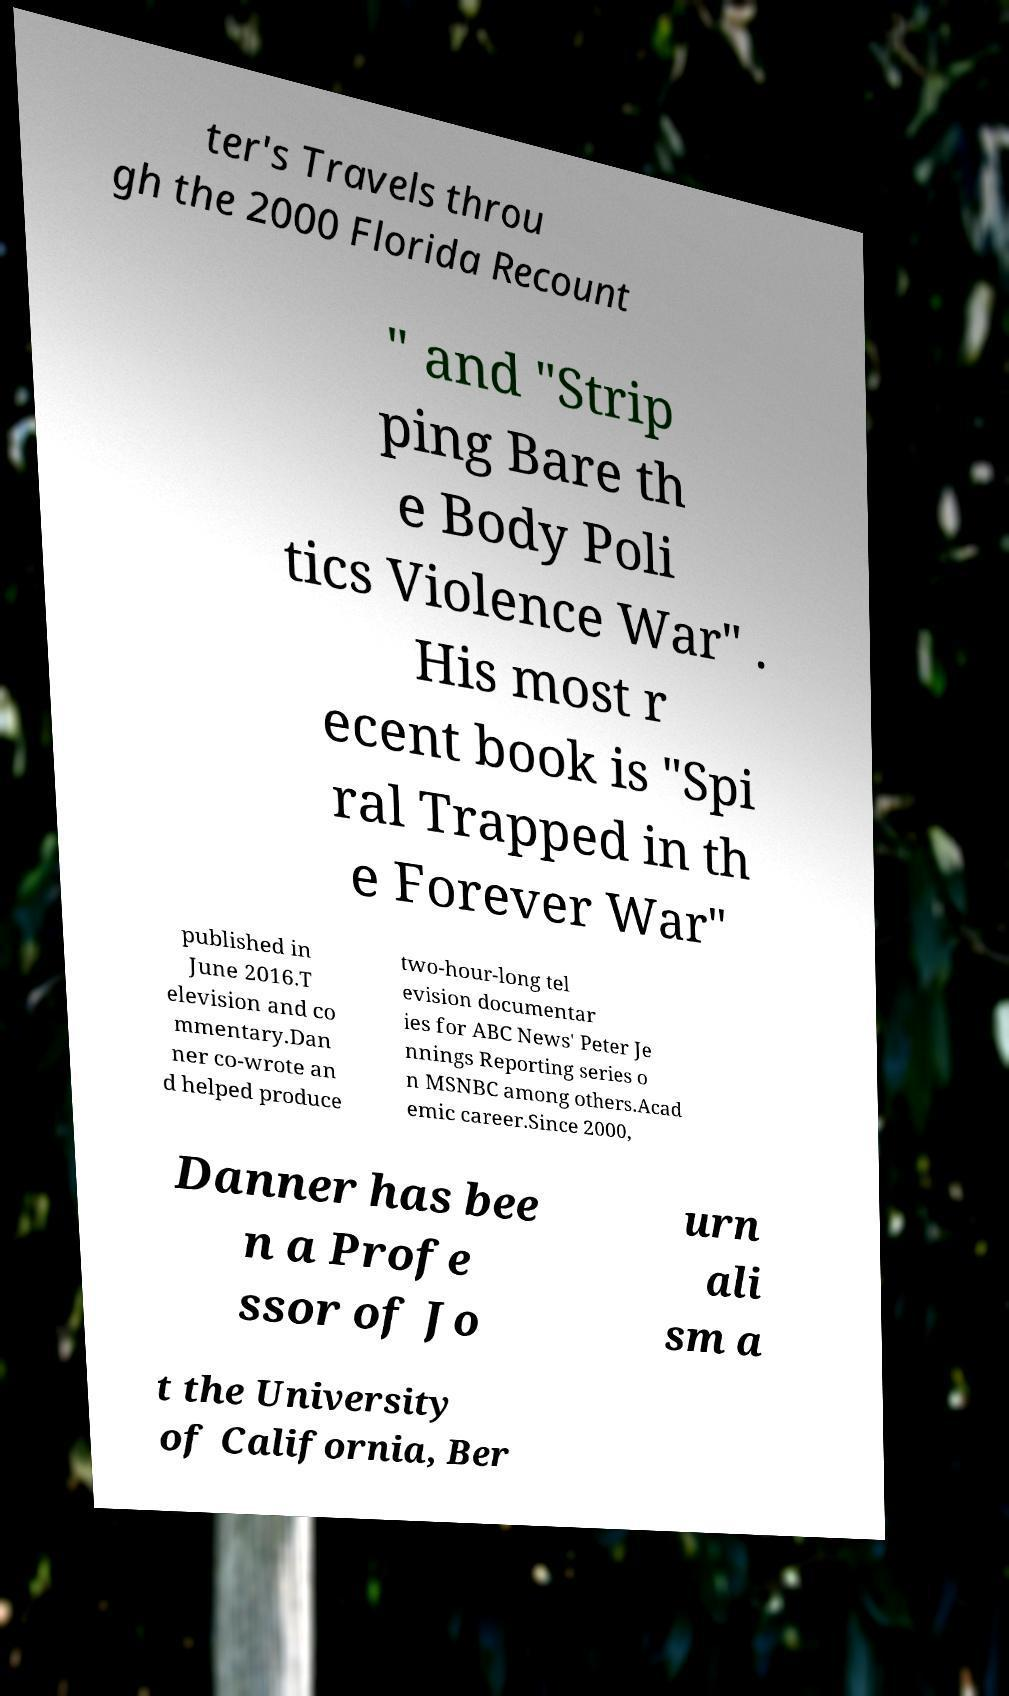What messages or text are displayed in this image? I need them in a readable, typed format. ter's Travels throu gh the 2000 Florida Recount " and "Strip ping Bare th e Body Poli tics Violence War" . His most r ecent book is "Spi ral Trapped in th e Forever War" published in June 2016.T elevision and co mmentary.Dan ner co-wrote an d helped produce two-hour-long tel evision documentar ies for ABC News' Peter Je nnings Reporting series o n MSNBC among others.Acad emic career.Since 2000, Danner has bee n a Profe ssor of Jo urn ali sm a t the University of California, Ber 